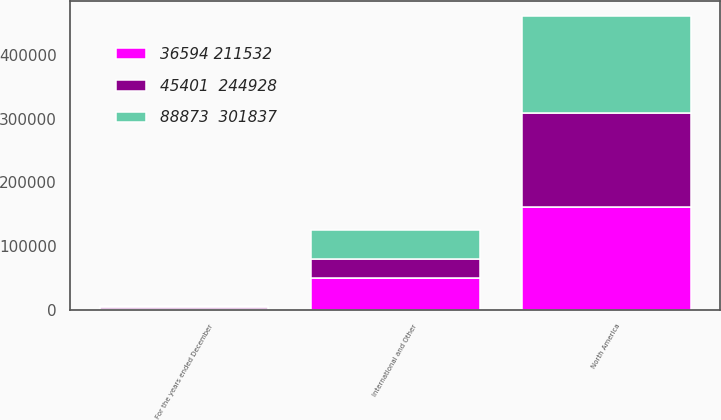Convert chart to OTSL. <chart><loc_0><loc_0><loc_500><loc_500><stacked_bar_chart><ecel><fcel>For the years ended December<fcel>North America<fcel>International and Other<nl><fcel>36594 211532<fcel>2016<fcel>162211<fcel>50753<nl><fcel>88873  301837<fcel>2015<fcel>153185<fcel>46342<nl><fcel>45401  244928<fcel>2014<fcel>146475<fcel>28463<nl></chart> 